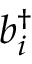<formula> <loc_0><loc_0><loc_500><loc_500>b _ { i } ^ { \dagger }</formula> 